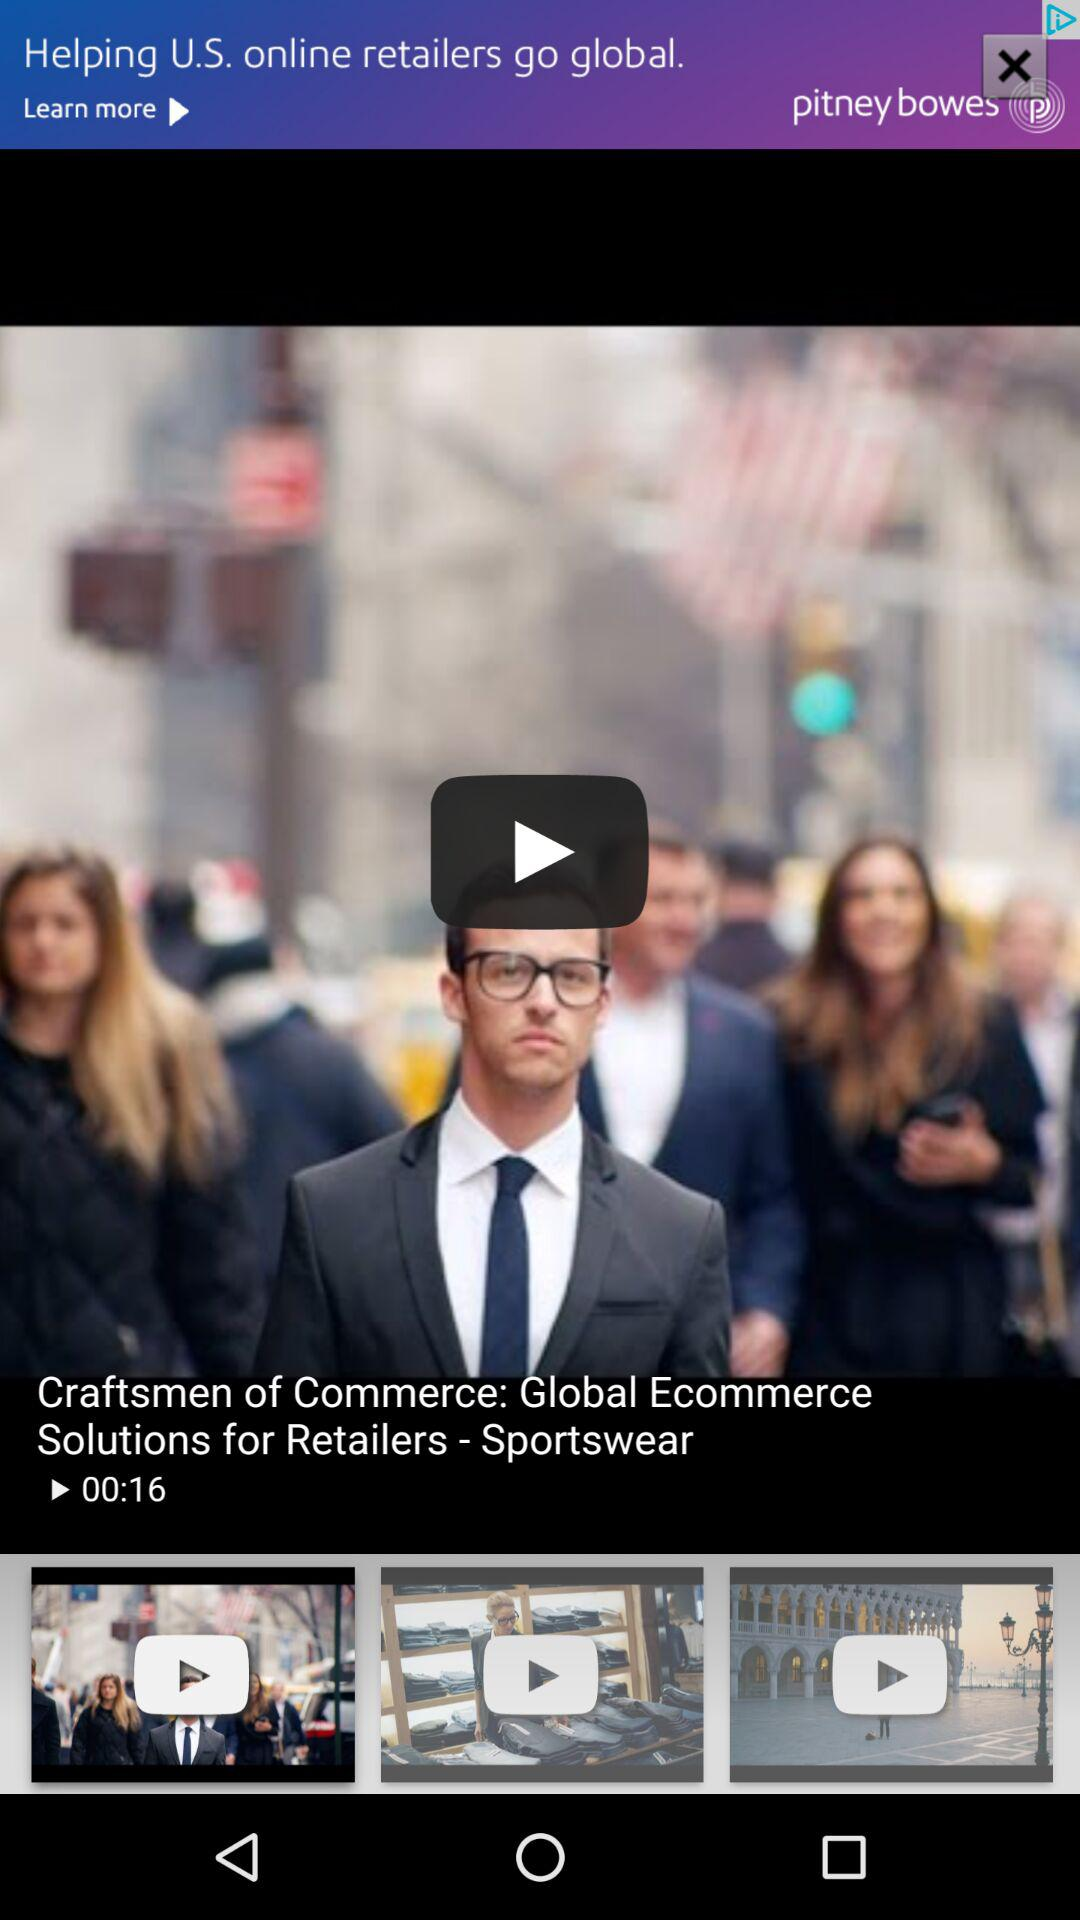How long is the video? The video is 16 seconds long. 